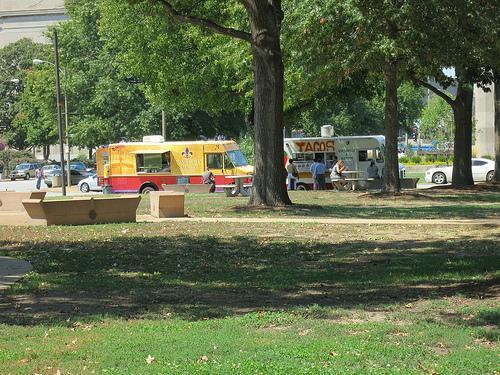How many tree trunks can you see?
Give a very brief answer. 3. How many vans are there?
Give a very brief answer. 2. 